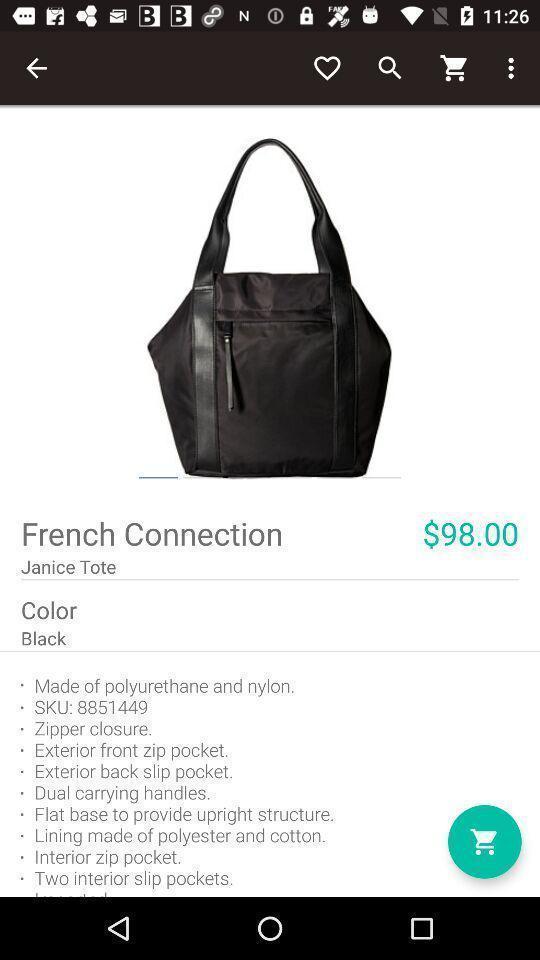Provide a textual representation of this image. Page showing details of a bag on a shopping app. 